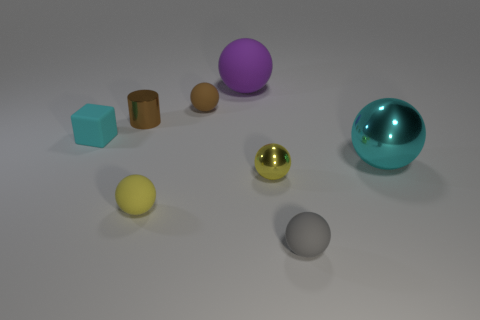Subtract 3 spheres. How many spheres are left? 3 Subtract all yellow spheres. How many spheres are left? 4 Subtract all small brown matte balls. How many balls are left? 5 Subtract all purple balls. Subtract all yellow cylinders. How many balls are left? 5 Add 1 red cylinders. How many objects exist? 9 Subtract all cubes. How many objects are left? 7 Add 3 small green shiny cubes. How many small green shiny cubes exist? 3 Subtract 0 red blocks. How many objects are left? 8 Subtract all purple matte spheres. Subtract all big cyan metal spheres. How many objects are left? 6 Add 7 gray balls. How many gray balls are left? 8 